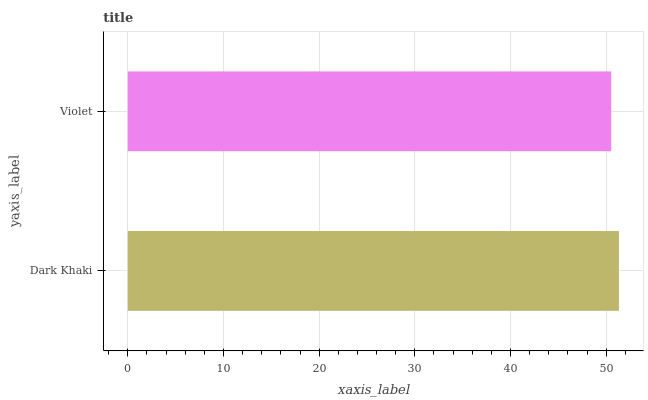Is Violet the minimum?
Answer yes or no. Yes. Is Dark Khaki the maximum?
Answer yes or no. Yes. Is Violet the maximum?
Answer yes or no. No. Is Dark Khaki greater than Violet?
Answer yes or no. Yes. Is Violet less than Dark Khaki?
Answer yes or no. Yes. Is Violet greater than Dark Khaki?
Answer yes or no. No. Is Dark Khaki less than Violet?
Answer yes or no. No. Is Dark Khaki the high median?
Answer yes or no. Yes. Is Violet the low median?
Answer yes or no. Yes. Is Violet the high median?
Answer yes or no. No. Is Dark Khaki the low median?
Answer yes or no. No. 